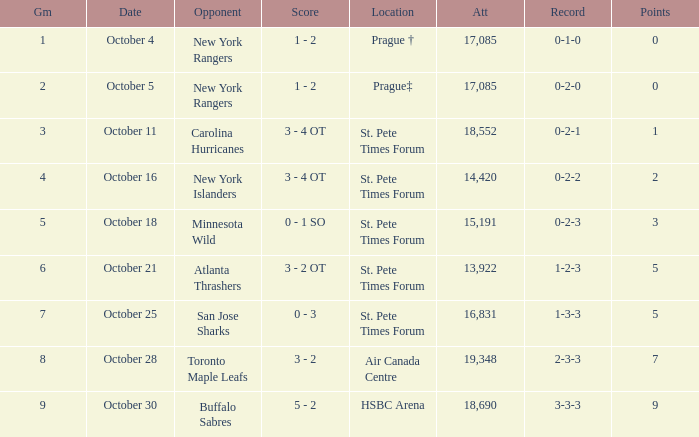What was the attendance when their record stood at 0-2-2? 14420.0. 